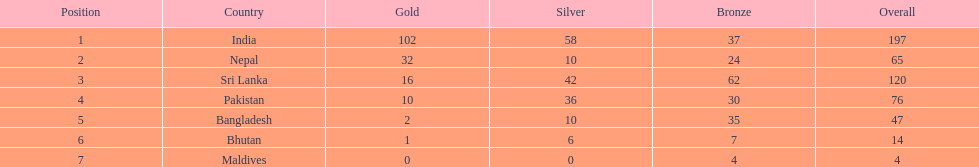What was the only nation to win less than 10 medals total? Maldives. 